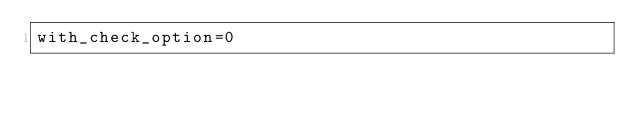<code> <loc_0><loc_0><loc_500><loc_500><_VisualBasic_>with_check_option=0</code> 